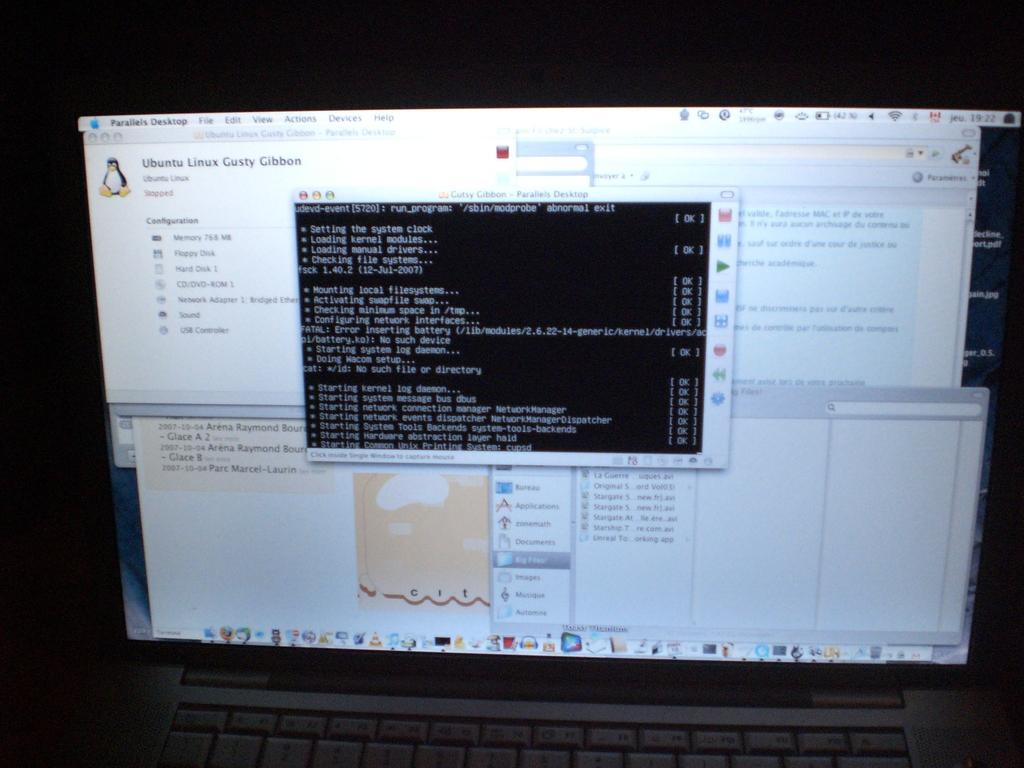<image>
Relay a brief, clear account of the picture shown. a laptop with many windows open on parallels desktop 